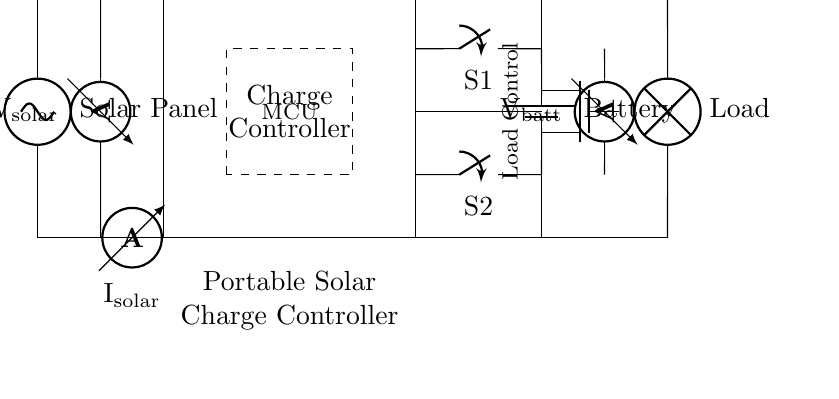What is the name of the component that regulates the solar input? The component that regulates the solar input is the Charge Controller, which is depicted as a rectangle in the diagram labeled as such.
Answer: Charge Controller What is the purpose of the switches S1 and S2? Switch S1 controls the connection between the charge controller and the battery, while switch S2 manages the connection between the charge controller and the load. Their functions can be inferred from their placement and associated labels.
Answer: Load and battery control What type of sensor is used to measure solar current? The sensor measuring solar current is an ammeter, represented in the diagram and labeled as solar current, which allows for current monitoring.
Answer: Ammeter What does the label "Tnmos" represent in the circuit? The label "Tnmos" refers to a type of transistor (specifically, a MOSFET) used for load control in the circuit. The diagram shows its function and indicates its importance in managing the load's power supply.
Answer: MOSFET How does the charge controller manage the battery charging? The charge controller manages battery charging by regulating input from the solar panel while preventing overcharging through its internal circuitry, signified by connections to the solar panel and battery.
Answer: Regulates solar input What readings do the voltmeters provide in this circuit? The voltmeters provide readings of the solar panel voltage and the battery voltage, which are key to monitoring the system's performance and ensuring proper operation. Their locations and labels in the diagram specify these voltage readings.
Answer: Solar and battery voltage Which component is responsible for load management in the circuit? The component responsible for load management is the MOSFET, labeled accordingly in the circuit, which facilitates control over how power is supplied to the load.
Answer: MOSFET 